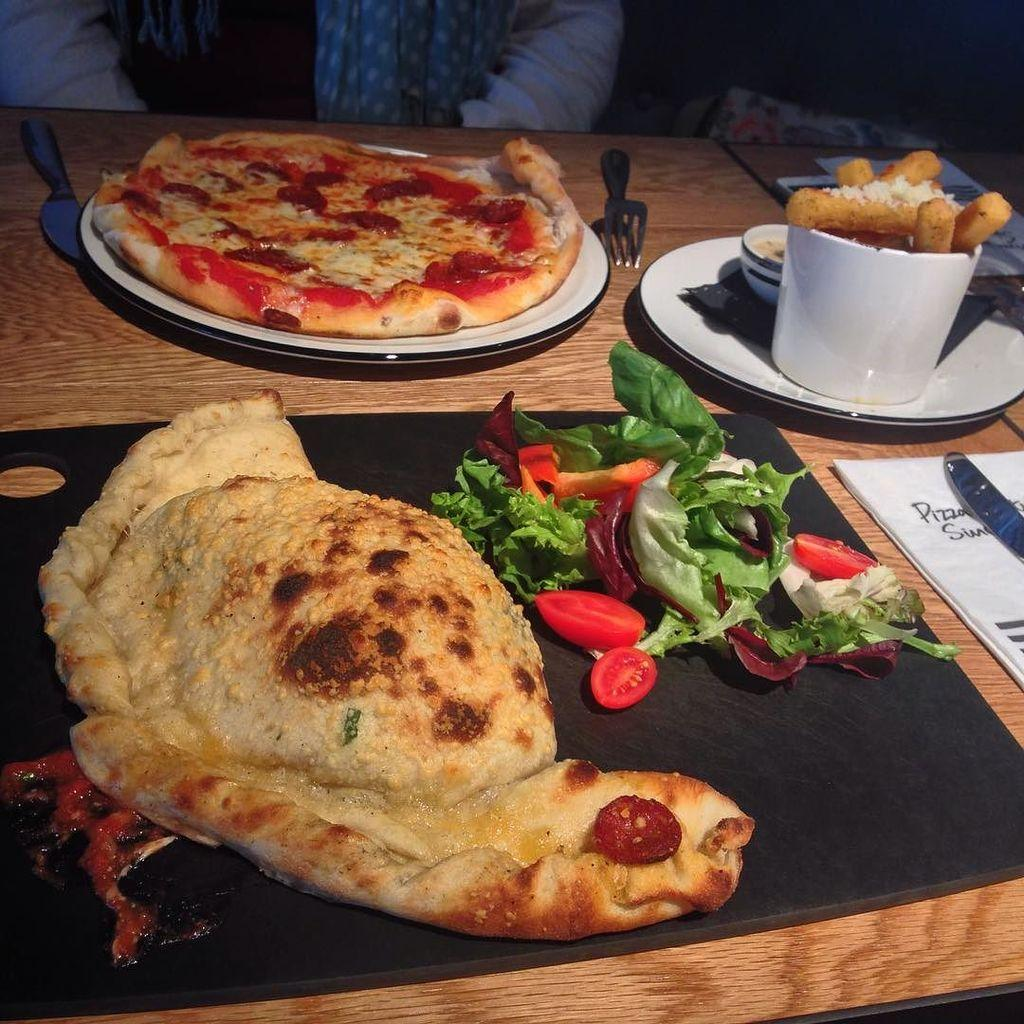What piece of furniture is present in the image? There is a table in the image. What can be found on the table? There is a food item and bowls on the table. Is there any paper on the table? Yes, there is a paper on the table. Can you describe the person visible in the image? The person is visible at the top of the image. What type of corn is being served as a joke on the tray in the image? There is no corn or tray present in the image. What type of joke is being told by the person in the image? The image does not depict a joke being told by the person. 